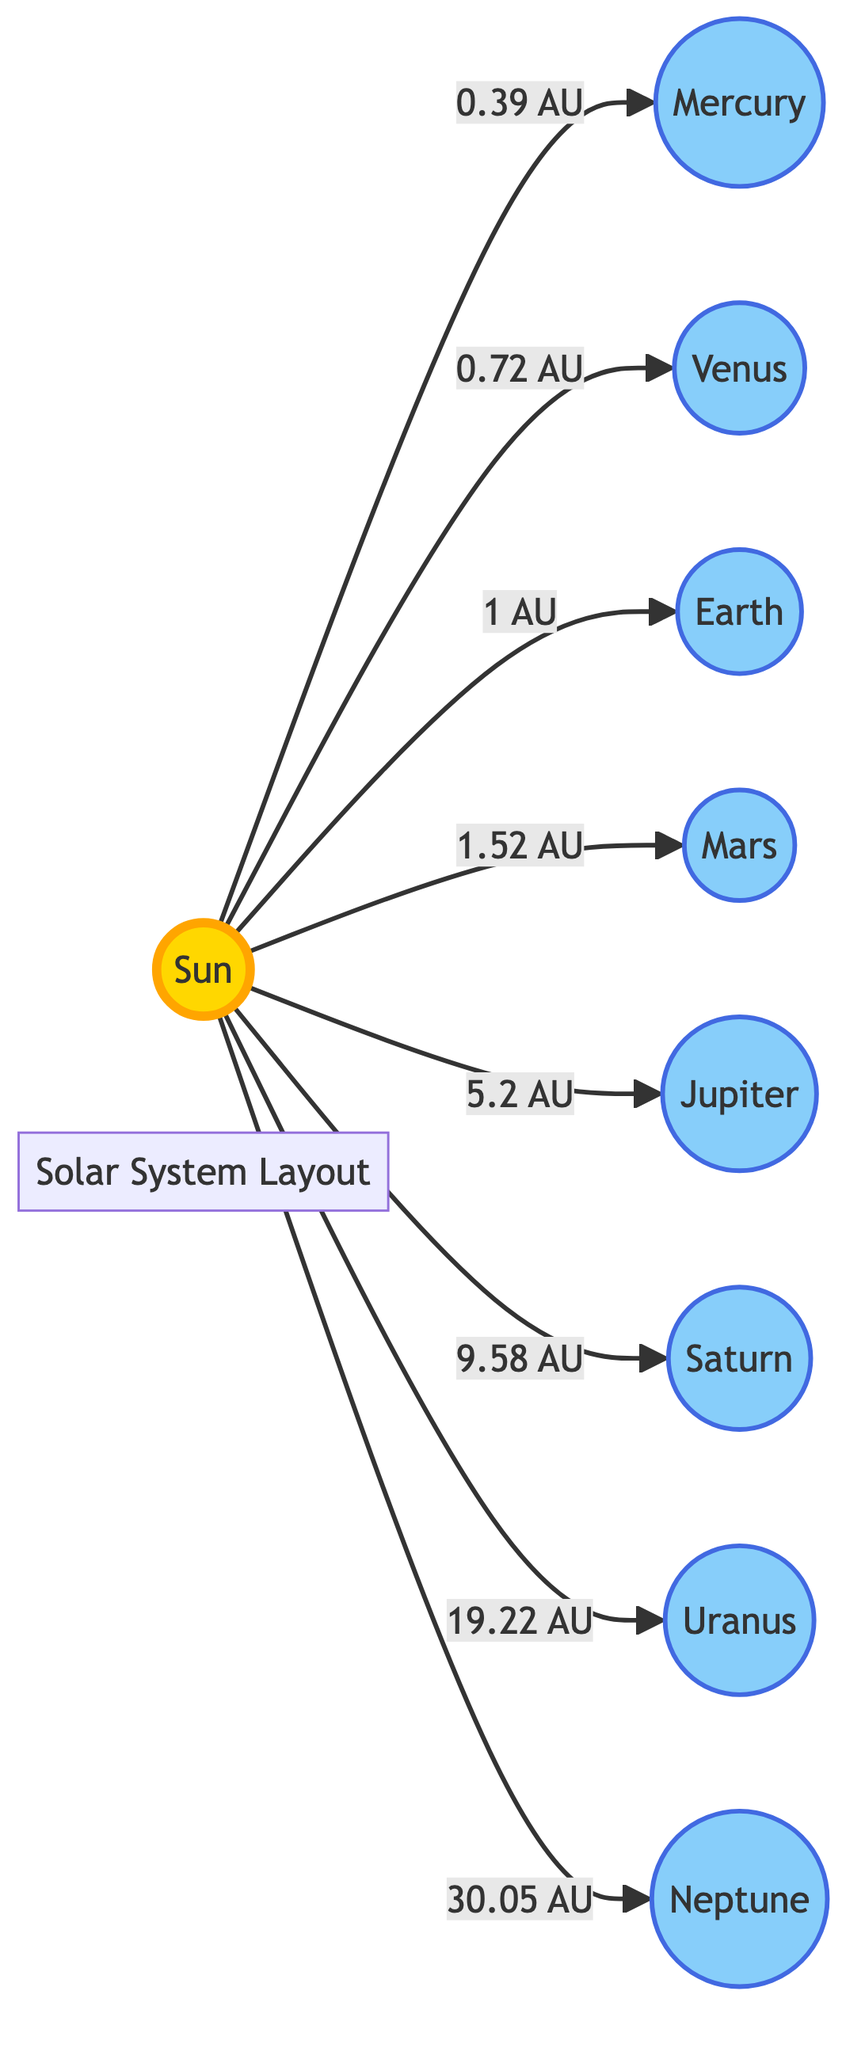What is the distance from the Sun to Mars? The diagram shows that the distance from the Sun to Mars is labeled as 1.52 AU, which indicates the astronomical unit measurement.
Answer: 1.52 AU Which planet is closest to the Sun? Looking at the flowchart, Mercury is the planet that is directly connected to the Sun and has the shortest distance listed at 0.39 AU.
Answer: Mercury How many planets are shown in the diagram? By counting the planetary nodes that are connected to the Sun, we find a total of 8 planets: Mercury, Venus, Earth, Mars, Jupiter, Saturn, Uranus, and Neptune.
Answer: 8 What is the distance from the Sun to Jupiter? The diagram specifies the distance from the Sun to Jupiter as 5.2 AU, as indicated next to the connection from the Sun to Jupiter.
Answer: 5.2 AU Which planet is the furthest from the Sun? Observing the distances listed in the diagram, Neptune has the longest distance, recorded as 30.05 AU from the Sun.
Answer: Neptune What is the total distance from the Sun to the outermost planet? The outermost planet is Neptune, which is 30.05 AU distant from the Sun as stated in the diagram.
Answer: 30.05 AU Which planet is the largest based on the font size in the diagram? The font size for Jupiter is the largest (22px), indicating its prominence and suggesting it is likely the largest planet represented in the diagram.
Answer: Jupiter What is the second planet from the Sun? The second planet in order of distance from the Sun, as shown in the diagram, is Venus, which is connected to the Sun with a distance of 0.72 AU.
Answer: Venus 